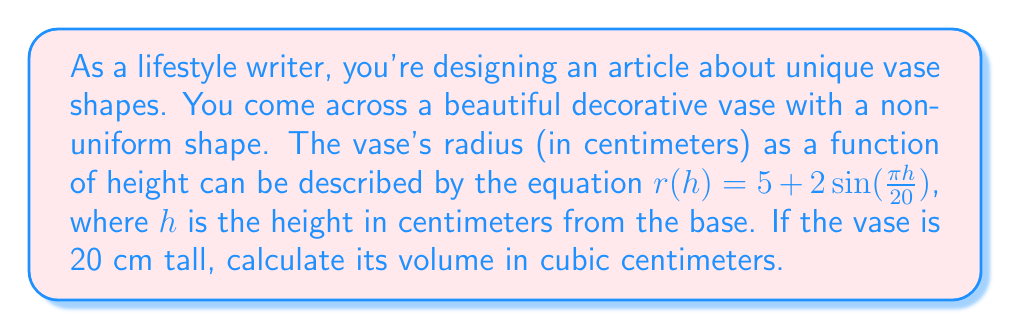Solve this math problem. To calculate the volume of a non-uniform vase, we need to use the formula for the volume of a solid of revolution:

$$V = \pi \int_0^H r^2(h) dh$$

Where $H$ is the total height of the vase, and $r(h)$ is the radius as a function of height.

Given:
- $r(h) = 5 + 2\sin(\frac{\pi h}{20})$
- $H = 20$ cm

Steps:
1) Substitute the given function into the volume formula:

   $$V = \pi \int_0^{20} (5 + 2\sin(\frac{\pi h}{20}))^2 dh$$

2) Expand the squared term:

   $$V = \pi \int_0^{20} (25 + 20\sin(\frac{\pi h}{20}) + 4\sin^2(\frac{\pi h}{20})) dh$$

3) Integrate each term separately:

   $$V = \pi [25h - \frac{400}{\pi}\cos(\frac{\pi h}{20}) + 2h - \frac{20}{\pi}\sin(\frac{2\pi h}{20})]_0^{20}$$

4) Evaluate the integral at the limits:

   $$V = \pi [(25 \cdot 20 - \frac{400}{\pi} \cdot (-1) + 2 \cdot 20 - 0) - (0 - \frac{400}{\pi} \cdot 1 + 0 - 0)]$$

5) Simplify:

   $$V = \pi (500 + \frac{400}{\pi} + 40 + \frac{400}{\pi}) = \pi (540 + \frac{800}{\pi})$$

6) Calculate the final result:

   $$V \approx 1,696.46 \text{ cm}^3$$
Answer: $\pi (540 + \frac{800}{\pi}) \approx 1,696.46 \text{ cm}^3$ 